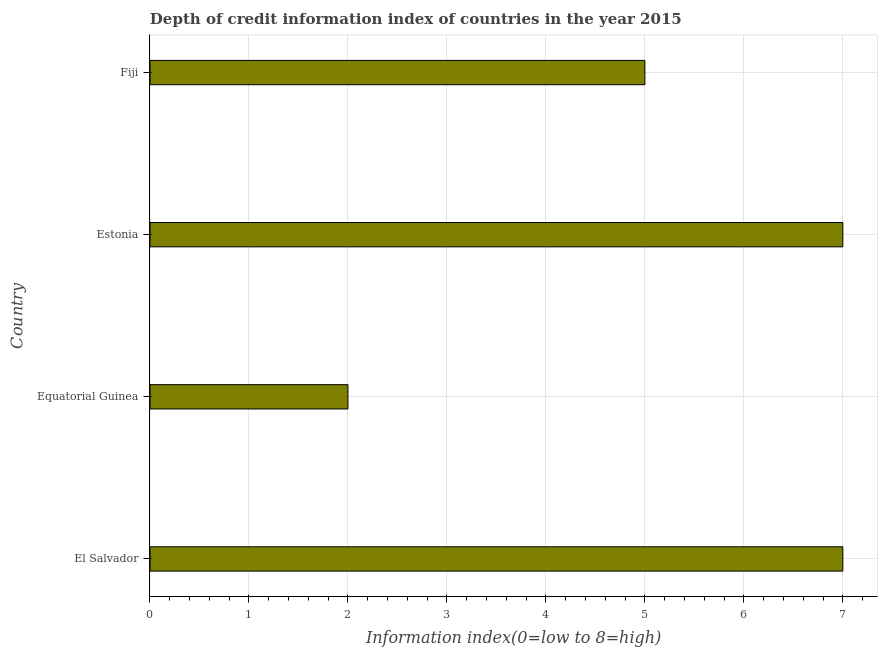Does the graph contain any zero values?
Provide a short and direct response. No. What is the title of the graph?
Keep it short and to the point. Depth of credit information index of countries in the year 2015. What is the label or title of the X-axis?
Make the answer very short. Information index(0=low to 8=high). Across all countries, what is the maximum depth of credit information index?
Ensure brevity in your answer.  7. In which country was the depth of credit information index maximum?
Provide a short and direct response. El Salvador. In which country was the depth of credit information index minimum?
Your answer should be very brief. Equatorial Guinea. What is the average depth of credit information index per country?
Your response must be concise. 5.25. What is the median depth of credit information index?
Provide a short and direct response. 6. In how many countries, is the depth of credit information index greater than 5.6 ?
Ensure brevity in your answer.  2. What is the ratio of the depth of credit information index in Equatorial Guinea to that in Estonia?
Provide a short and direct response. 0.29. Is the difference between the depth of credit information index in Estonia and Fiji greater than the difference between any two countries?
Make the answer very short. No. What is the difference between the highest and the lowest depth of credit information index?
Your answer should be compact. 5. Are all the bars in the graph horizontal?
Ensure brevity in your answer.  Yes. What is the difference between two consecutive major ticks on the X-axis?
Your response must be concise. 1. What is the Information index(0=low to 8=high) of Fiji?
Make the answer very short. 5. What is the difference between the Information index(0=low to 8=high) in El Salvador and Equatorial Guinea?
Keep it short and to the point. 5. What is the difference between the Information index(0=low to 8=high) in El Salvador and Estonia?
Your answer should be very brief. 0. What is the difference between the Information index(0=low to 8=high) in Equatorial Guinea and Fiji?
Provide a short and direct response. -3. What is the difference between the Information index(0=low to 8=high) in Estonia and Fiji?
Ensure brevity in your answer.  2. What is the ratio of the Information index(0=low to 8=high) in El Salvador to that in Estonia?
Your answer should be compact. 1. What is the ratio of the Information index(0=low to 8=high) in Equatorial Guinea to that in Estonia?
Give a very brief answer. 0.29. What is the ratio of the Information index(0=low to 8=high) in Equatorial Guinea to that in Fiji?
Provide a succinct answer. 0.4. 